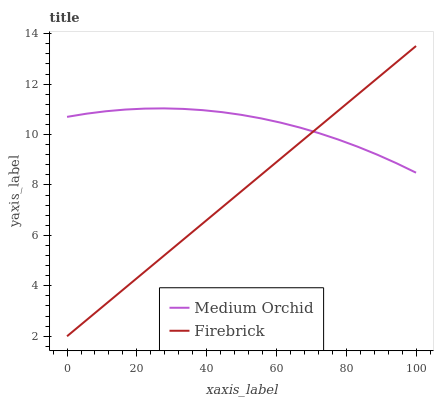Does Firebrick have the minimum area under the curve?
Answer yes or no. Yes. Does Medium Orchid have the maximum area under the curve?
Answer yes or no. Yes. Does Medium Orchid have the minimum area under the curve?
Answer yes or no. No. Is Firebrick the smoothest?
Answer yes or no. Yes. Is Medium Orchid the roughest?
Answer yes or no. Yes. Is Medium Orchid the smoothest?
Answer yes or no. No. Does Firebrick have the lowest value?
Answer yes or no. Yes. Does Medium Orchid have the lowest value?
Answer yes or no. No. Does Firebrick have the highest value?
Answer yes or no. Yes. Does Medium Orchid have the highest value?
Answer yes or no. No. Does Firebrick intersect Medium Orchid?
Answer yes or no. Yes. Is Firebrick less than Medium Orchid?
Answer yes or no. No. Is Firebrick greater than Medium Orchid?
Answer yes or no. No. 